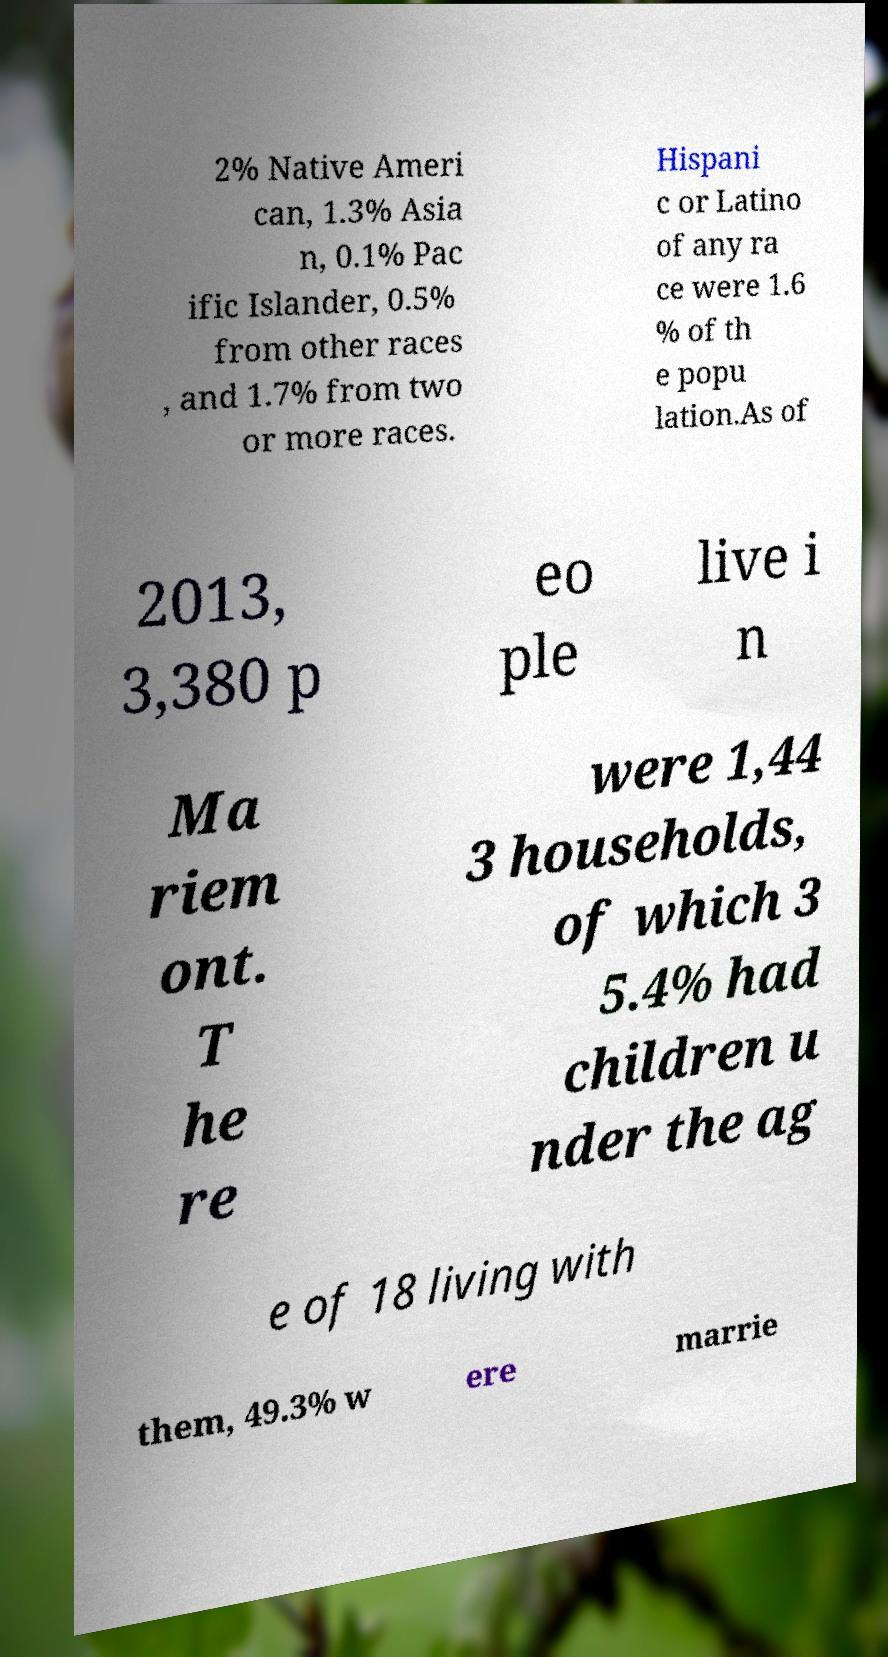Can you read and provide the text displayed in the image?This photo seems to have some interesting text. Can you extract and type it out for me? 2% Native Ameri can, 1.3% Asia n, 0.1% Pac ific Islander, 0.5% from other races , and 1.7% from two or more races. Hispani c or Latino of any ra ce were 1.6 % of th e popu lation.As of 2013, 3,380 p eo ple live i n Ma riem ont. T he re were 1,44 3 households, of which 3 5.4% had children u nder the ag e of 18 living with them, 49.3% w ere marrie 